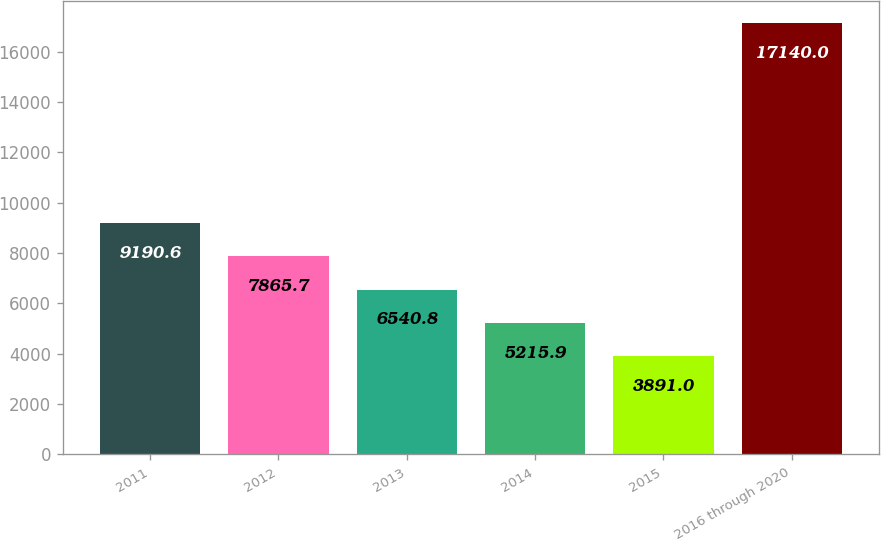<chart> <loc_0><loc_0><loc_500><loc_500><bar_chart><fcel>2011<fcel>2012<fcel>2013<fcel>2014<fcel>2015<fcel>2016 through 2020<nl><fcel>9190.6<fcel>7865.7<fcel>6540.8<fcel>5215.9<fcel>3891<fcel>17140<nl></chart> 